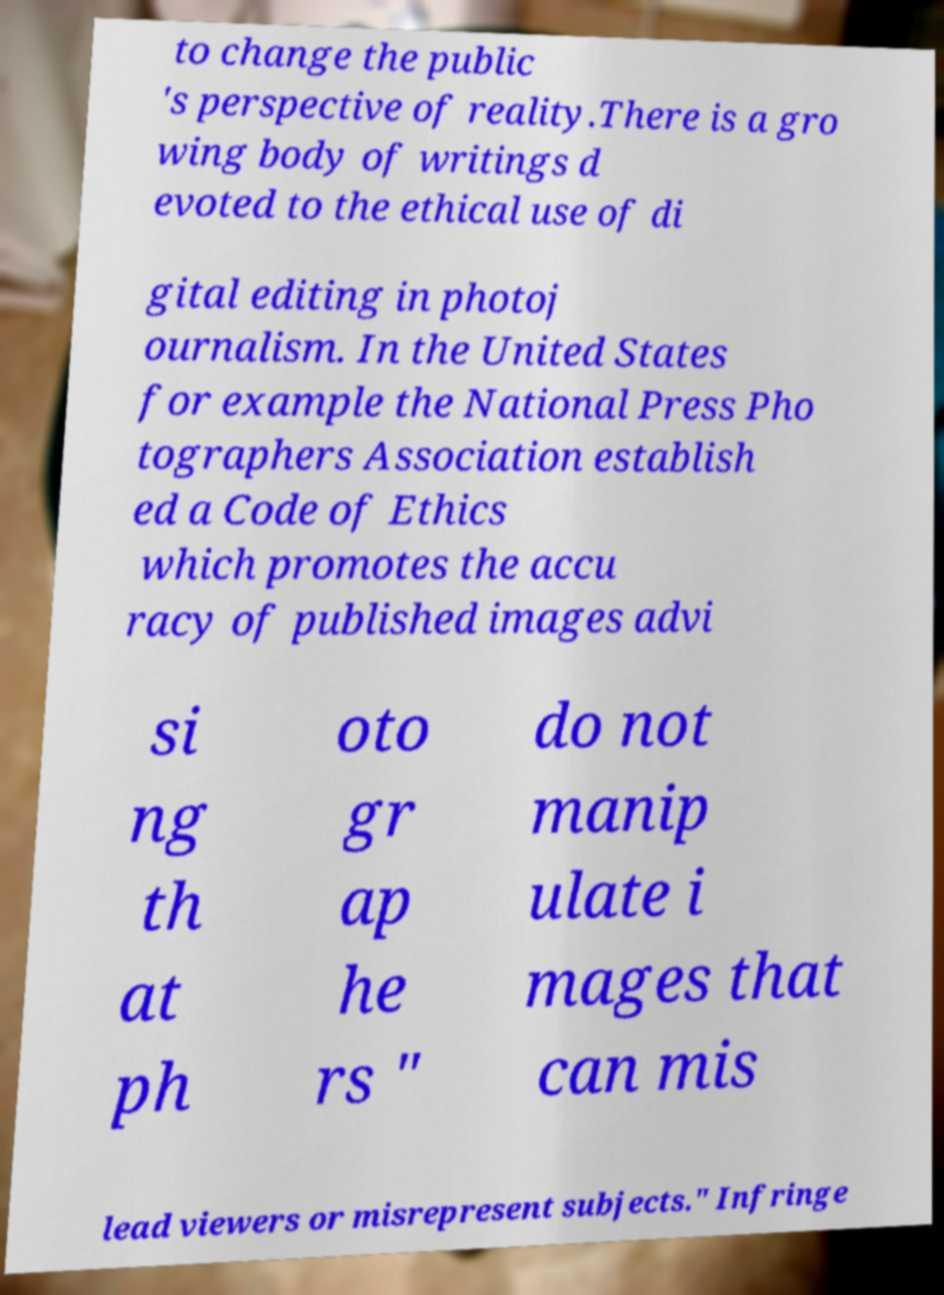Can you accurately transcribe the text from the provided image for me? to change the public 's perspective of reality.There is a gro wing body of writings d evoted to the ethical use of di gital editing in photoj ournalism. In the United States for example the National Press Pho tographers Association establish ed a Code of Ethics which promotes the accu racy of published images advi si ng th at ph oto gr ap he rs " do not manip ulate i mages that can mis lead viewers or misrepresent subjects." Infringe 